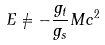Convert formula to latex. <formula><loc_0><loc_0><loc_500><loc_500>E \neq - \frac { g _ { t } } { g _ { s } } M c ^ { 2 }</formula> 